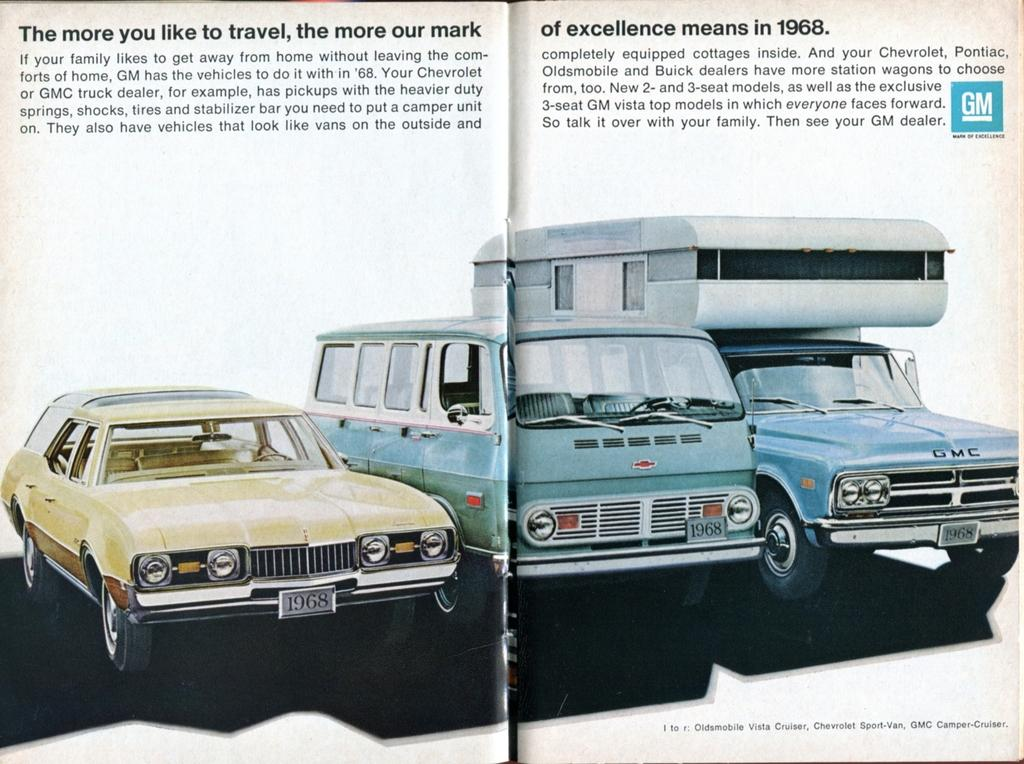<image>
Offer a succinct explanation of the picture presented. A 2-page GM ad from 1968 promotes their mark of excellence and features several vehicles. 